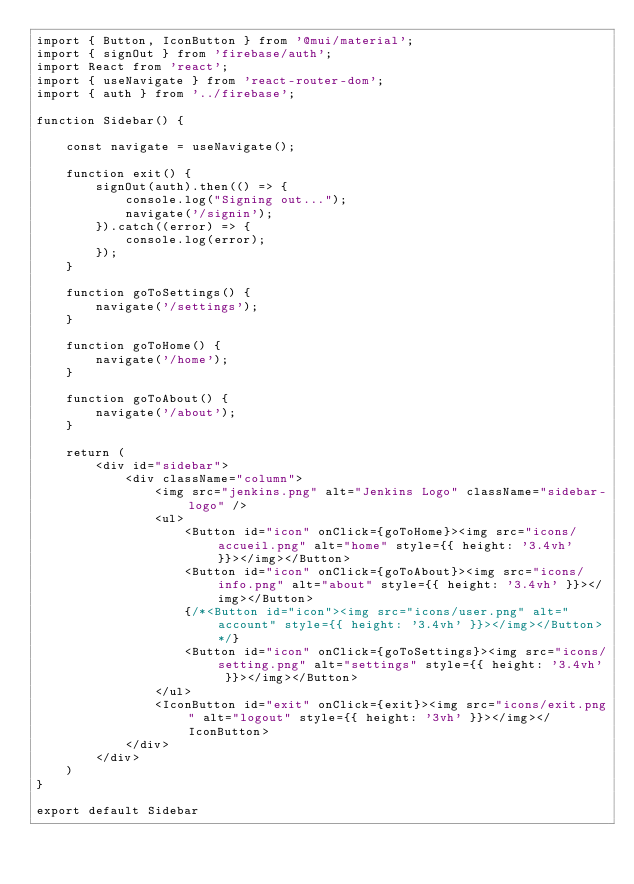<code> <loc_0><loc_0><loc_500><loc_500><_JavaScript_>import { Button, IconButton } from '@mui/material';
import { signOut } from 'firebase/auth';
import React from 'react';
import { useNavigate } from 'react-router-dom';
import { auth } from '../firebase';

function Sidebar() {

    const navigate = useNavigate();

    function exit() {
        signOut(auth).then(() => {
            console.log("Signing out...");
            navigate('/signin');
        }).catch((error) => {
            console.log(error);
        });
    }

    function goToSettings() {
        navigate('/settings');
    }

    function goToHome() {
        navigate('/home');
    }

    function goToAbout() {
        navigate('/about');
    }

    return (
        <div id="sidebar">
            <div className="column">
                <img src="jenkins.png" alt="Jenkins Logo" className="sidebar-logo" />
                <ul>
                    <Button id="icon" onClick={goToHome}><img src="icons/accueil.png" alt="home" style={{ height: '3.4vh' }}></img></Button>
                    <Button id="icon" onClick={goToAbout}><img src="icons/info.png" alt="about" style={{ height: '3.4vh' }}></img></Button>
                    {/*<Button id="icon"><img src="icons/user.png" alt="account" style={{ height: '3.4vh' }}></img></Button>*/}
                    <Button id="icon" onClick={goToSettings}><img src="icons/setting.png" alt="settings" style={{ height: '3.4vh' }}></img></Button>
                </ul>
                <IconButton id="exit" onClick={exit}><img src="icons/exit.png" alt="logout" style={{ height: '3vh' }}></img></IconButton>
            </div>
        </div>
    )
}

export default Sidebar
</code> 